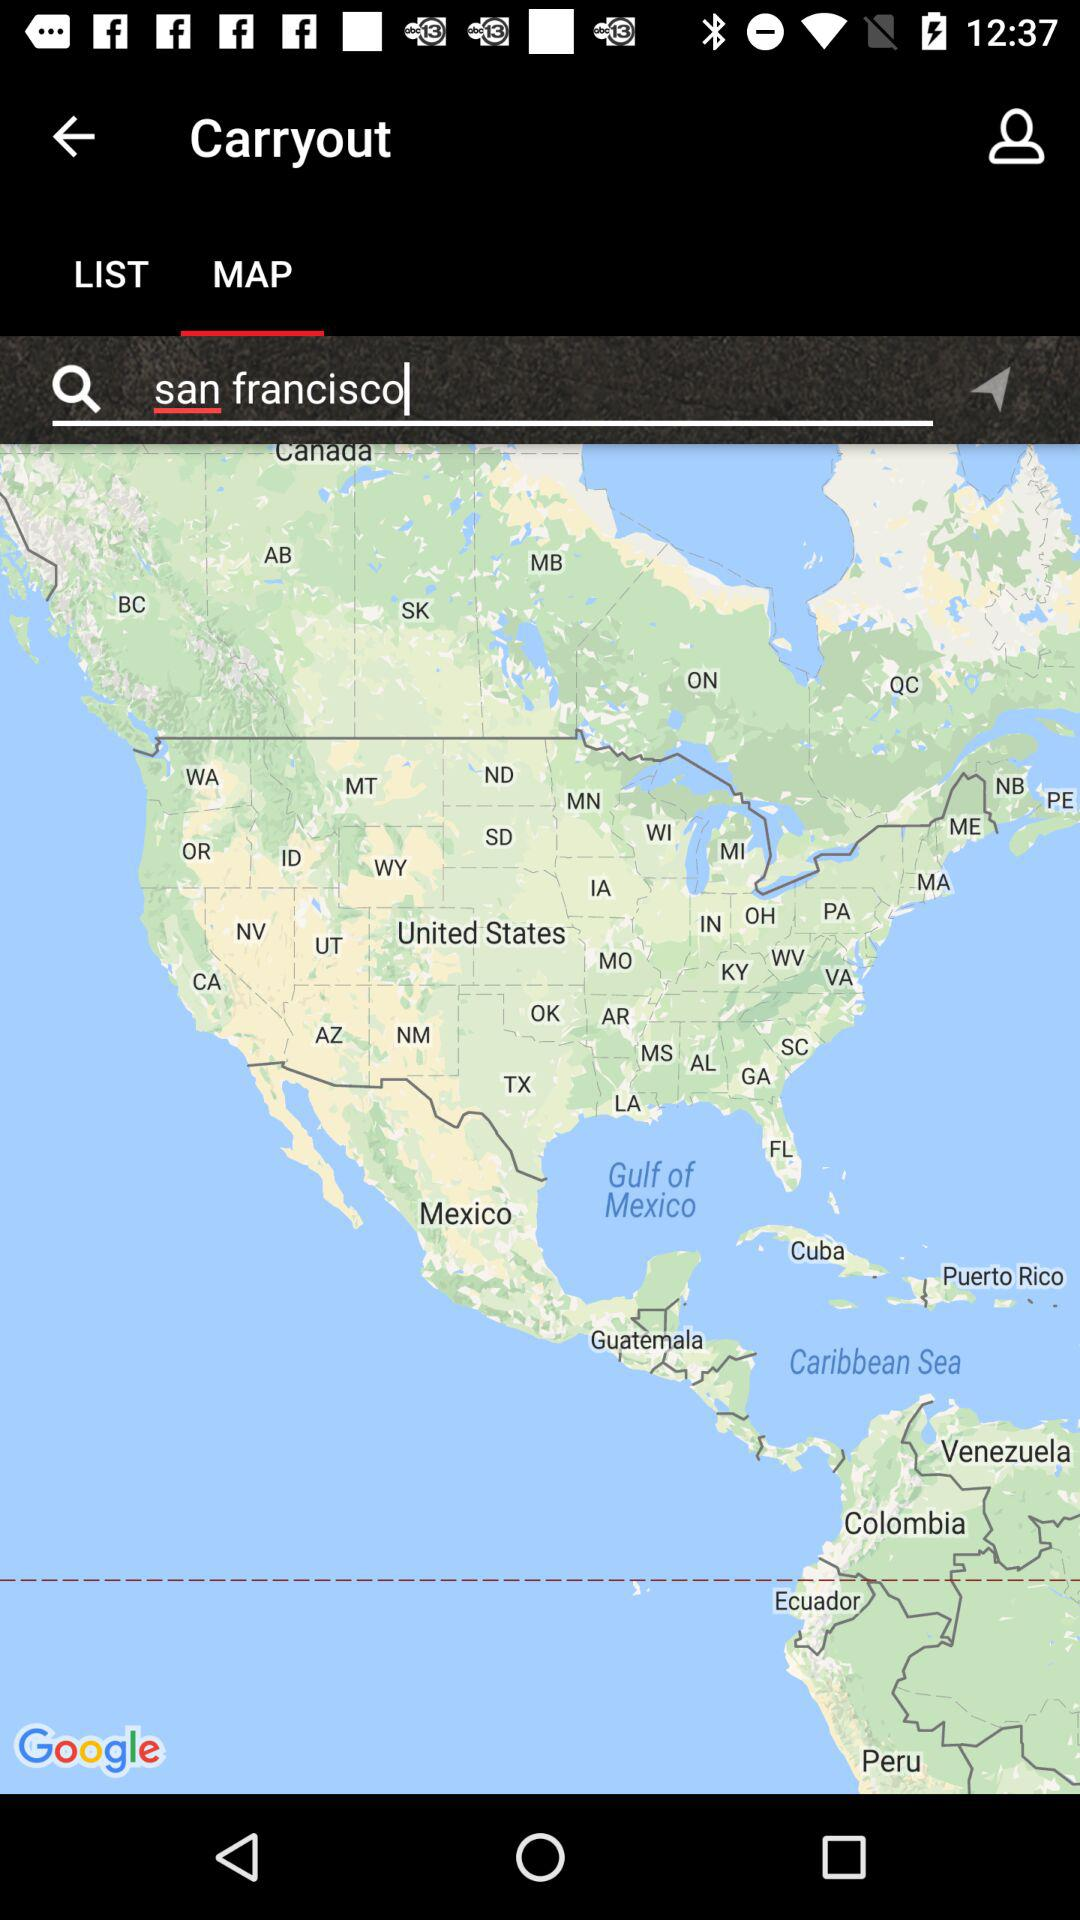What is the location? The location is San Francisco. 